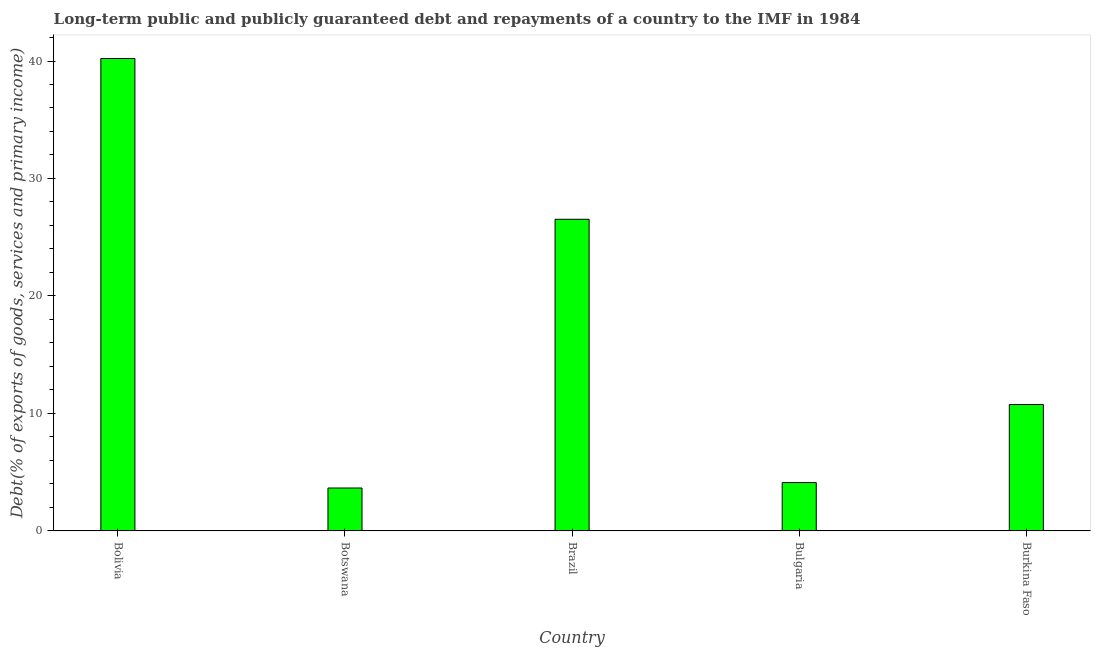Does the graph contain any zero values?
Make the answer very short. No. What is the title of the graph?
Provide a short and direct response. Long-term public and publicly guaranteed debt and repayments of a country to the IMF in 1984. What is the label or title of the Y-axis?
Your response must be concise. Debt(% of exports of goods, services and primary income). What is the debt service in Botswana?
Offer a terse response. 3.65. Across all countries, what is the maximum debt service?
Provide a short and direct response. 40.21. Across all countries, what is the minimum debt service?
Your answer should be compact. 3.65. In which country was the debt service maximum?
Your answer should be very brief. Bolivia. In which country was the debt service minimum?
Your answer should be very brief. Botswana. What is the sum of the debt service?
Your answer should be very brief. 85.28. What is the difference between the debt service in Bulgaria and Burkina Faso?
Keep it short and to the point. -6.64. What is the average debt service per country?
Offer a terse response. 17.05. What is the median debt service?
Make the answer very short. 10.76. What is the ratio of the debt service in Bolivia to that in Botswana?
Keep it short and to the point. 11. Is the debt service in Botswana less than that in Burkina Faso?
Ensure brevity in your answer.  Yes. What is the difference between the highest and the second highest debt service?
Your response must be concise. 13.69. What is the difference between the highest and the lowest debt service?
Offer a terse response. 36.56. How many bars are there?
Offer a very short reply. 5. Are all the bars in the graph horizontal?
Provide a succinct answer. No. What is the Debt(% of exports of goods, services and primary income) in Bolivia?
Your answer should be compact. 40.21. What is the Debt(% of exports of goods, services and primary income) of Botswana?
Offer a terse response. 3.65. What is the Debt(% of exports of goods, services and primary income) of Brazil?
Your response must be concise. 26.53. What is the Debt(% of exports of goods, services and primary income) of Bulgaria?
Ensure brevity in your answer.  4.12. What is the Debt(% of exports of goods, services and primary income) in Burkina Faso?
Give a very brief answer. 10.76. What is the difference between the Debt(% of exports of goods, services and primary income) in Bolivia and Botswana?
Make the answer very short. 36.56. What is the difference between the Debt(% of exports of goods, services and primary income) in Bolivia and Brazil?
Your response must be concise. 13.69. What is the difference between the Debt(% of exports of goods, services and primary income) in Bolivia and Bulgaria?
Offer a very short reply. 36.09. What is the difference between the Debt(% of exports of goods, services and primary income) in Bolivia and Burkina Faso?
Keep it short and to the point. 29.45. What is the difference between the Debt(% of exports of goods, services and primary income) in Botswana and Brazil?
Give a very brief answer. -22.87. What is the difference between the Debt(% of exports of goods, services and primary income) in Botswana and Bulgaria?
Your answer should be compact. -0.46. What is the difference between the Debt(% of exports of goods, services and primary income) in Botswana and Burkina Faso?
Your answer should be compact. -7.11. What is the difference between the Debt(% of exports of goods, services and primary income) in Brazil and Bulgaria?
Provide a short and direct response. 22.41. What is the difference between the Debt(% of exports of goods, services and primary income) in Brazil and Burkina Faso?
Your response must be concise. 15.77. What is the difference between the Debt(% of exports of goods, services and primary income) in Bulgaria and Burkina Faso?
Offer a very short reply. -6.64. What is the ratio of the Debt(% of exports of goods, services and primary income) in Bolivia to that in Botswana?
Your answer should be very brief. 11. What is the ratio of the Debt(% of exports of goods, services and primary income) in Bolivia to that in Brazil?
Give a very brief answer. 1.52. What is the ratio of the Debt(% of exports of goods, services and primary income) in Bolivia to that in Bulgaria?
Provide a short and direct response. 9.76. What is the ratio of the Debt(% of exports of goods, services and primary income) in Bolivia to that in Burkina Faso?
Your response must be concise. 3.74. What is the ratio of the Debt(% of exports of goods, services and primary income) in Botswana to that in Brazil?
Offer a terse response. 0.14. What is the ratio of the Debt(% of exports of goods, services and primary income) in Botswana to that in Bulgaria?
Offer a very short reply. 0.89. What is the ratio of the Debt(% of exports of goods, services and primary income) in Botswana to that in Burkina Faso?
Your answer should be very brief. 0.34. What is the ratio of the Debt(% of exports of goods, services and primary income) in Brazil to that in Bulgaria?
Your answer should be compact. 6.44. What is the ratio of the Debt(% of exports of goods, services and primary income) in Brazil to that in Burkina Faso?
Your response must be concise. 2.46. What is the ratio of the Debt(% of exports of goods, services and primary income) in Bulgaria to that in Burkina Faso?
Your response must be concise. 0.38. 